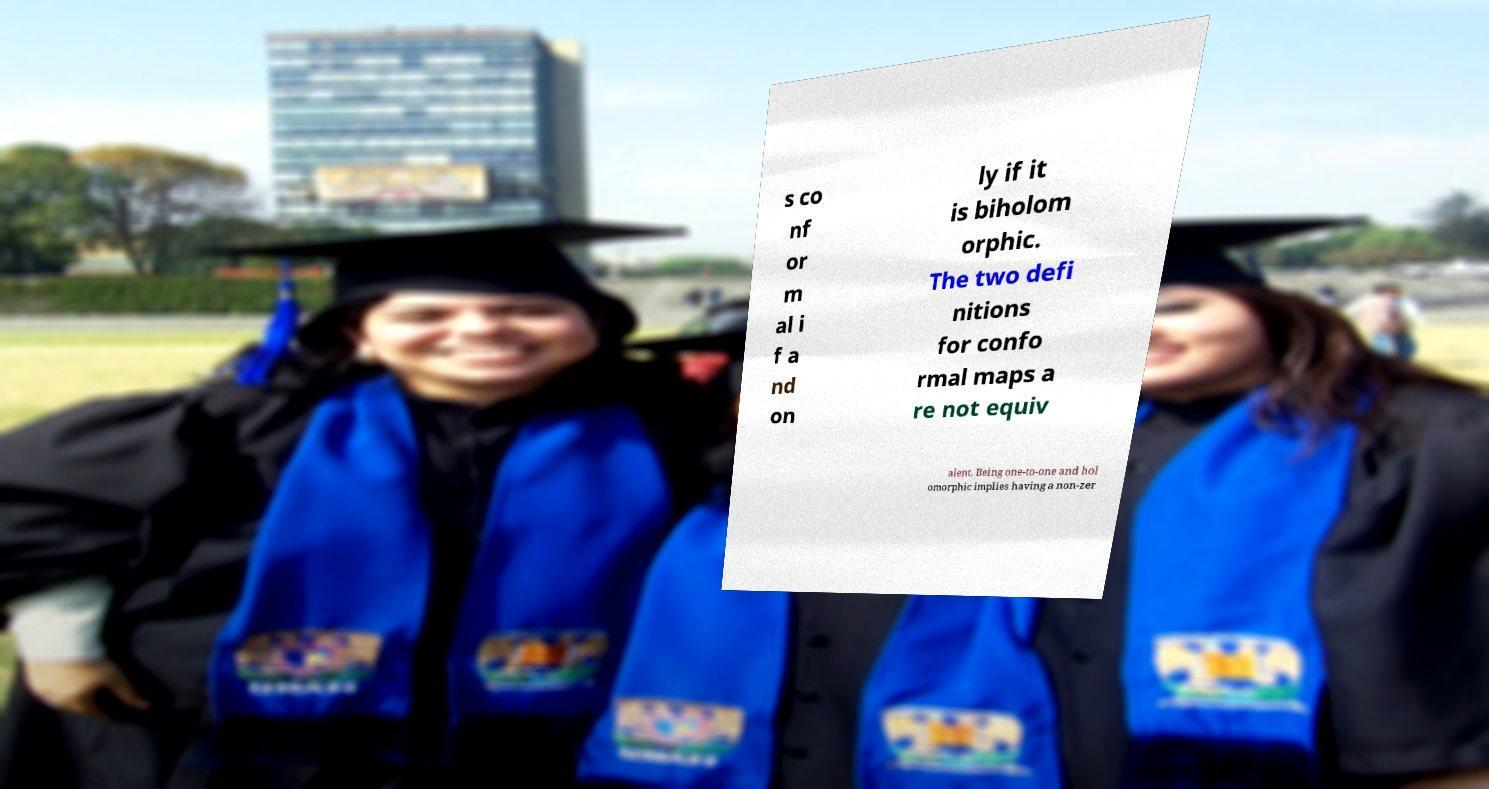I need the written content from this picture converted into text. Can you do that? s co nf or m al i f a nd on ly if it is biholom orphic. The two defi nitions for confo rmal maps a re not equiv alent. Being one-to-one and hol omorphic implies having a non-zer 